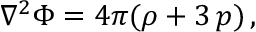<formula> <loc_0><loc_0><loc_500><loc_500>\nabla ^ { 2 } \Phi = 4 \pi ( \rho + 3 \, p ) \, ,</formula> 